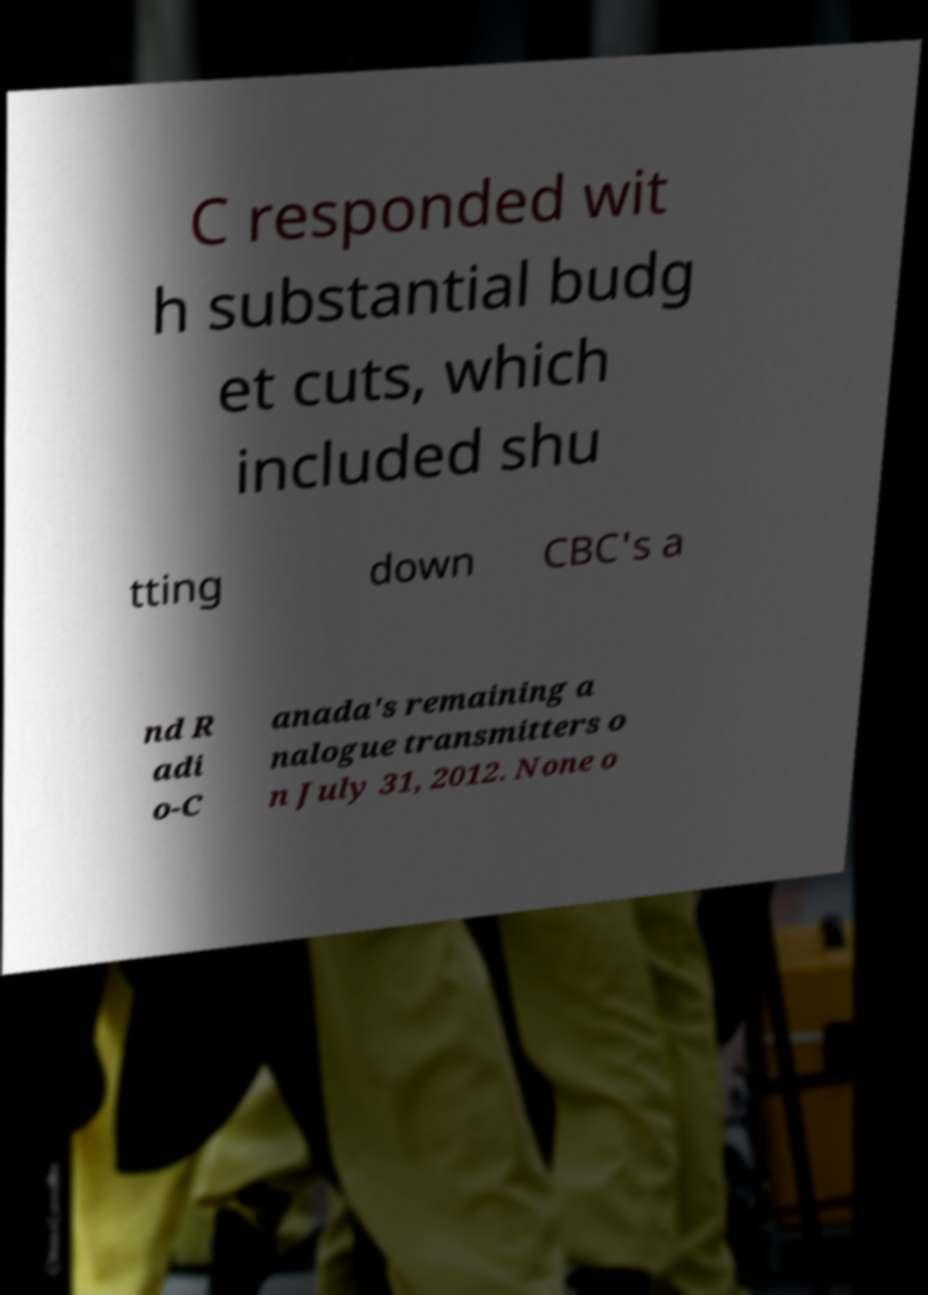Can you accurately transcribe the text from the provided image for me? C responded wit h substantial budg et cuts, which included shu tting down CBC's a nd R adi o-C anada's remaining a nalogue transmitters o n July 31, 2012. None o 